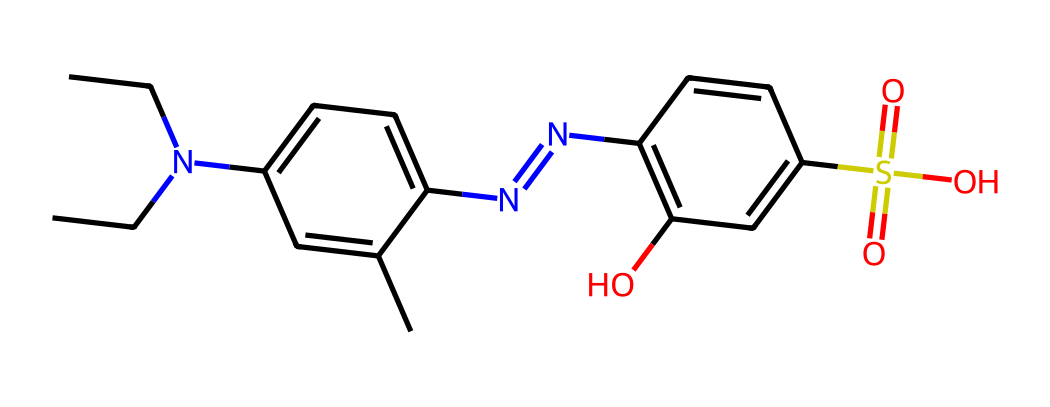What is the total number of carbon atoms in the structure? By examining the SMILES representation, we can identify each 'C' in the chain and the rings, counting a total of 12 carbon atoms.
Answer: 12 How many nitrogen atoms are present in this structure? In the SMILES notation, 'N' denotes nitrogen atoms. There are two 'N's visible, indicating the presence of 2 nitrogen atoms in the structure.
Answer: 2 What functional group is represented by the "S(=O)(=O)O" part of the chemical? The "S(=O)(=O)O" indicates a sulfonic acid group (-SO3H) due to the sulfur atom bonded to three oxygen atoms, with one of them being a hydroxyl (-OH) group.
Answer: sulfonic acid Can this chemical be classified as an electron-withdrawing or an electron-donating group? The nitrogen atoms in the structure can act as electron donors due to their lone pair of electrons, which typically enhances the electron density of the compound.
Answer: electron-donating What type of interaction would the sulfonic acid group have with water? The sulfonic acid group, due to its -SO3H nature, is highly polar and can readily form hydrogen bonds with water molecules, making it hydrophilic.
Answer: hydrophilic What type of chromophore is suggested by the multiple conjugated double bonds in the structure? The presence of extended conjugation in the form of alternating double bonds (the benzene-like rings) indicates that this compound likely has an aromatic chromophore, which can absorb light.
Answer: aromatic chromophore How does the presence of nitrogen most likely affect the dye's affinity to the fabric? Nitrogen atoms can participate in hydrogen bonding with fabric fibers, enhancing the dye's affinity due to the ability to form stable interactions with polar functional groups on the fabric.
Answer: increased affinity 